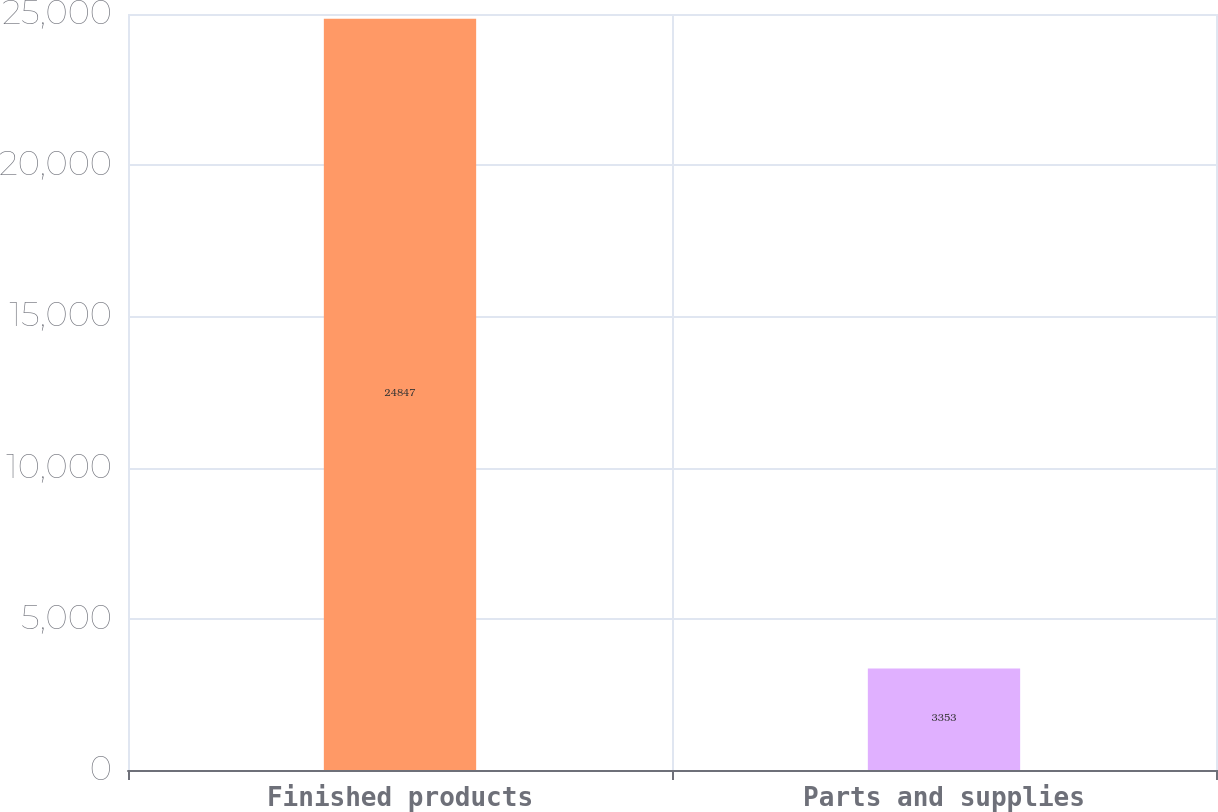Convert chart. <chart><loc_0><loc_0><loc_500><loc_500><bar_chart><fcel>Finished products<fcel>Parts and supplies<nl><fcel>24847<fcel>3353<nl></chart> 